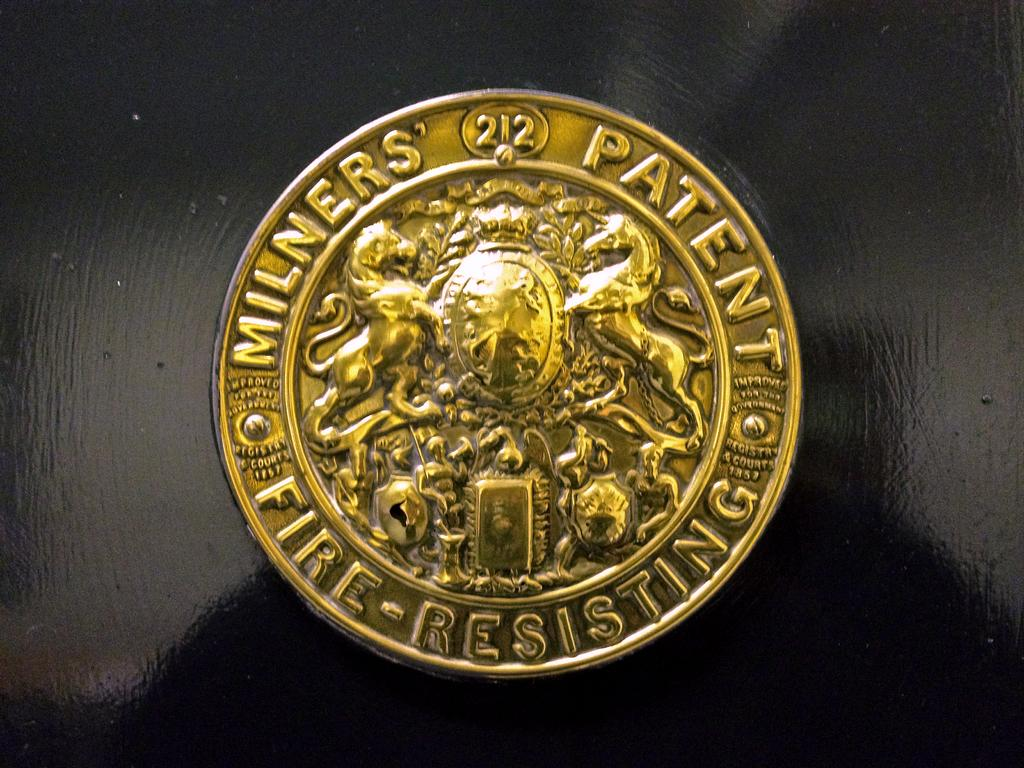Provide a one-sentence caption for the provided image. A gold button with Milners' Patent Fire Resistant on it. 